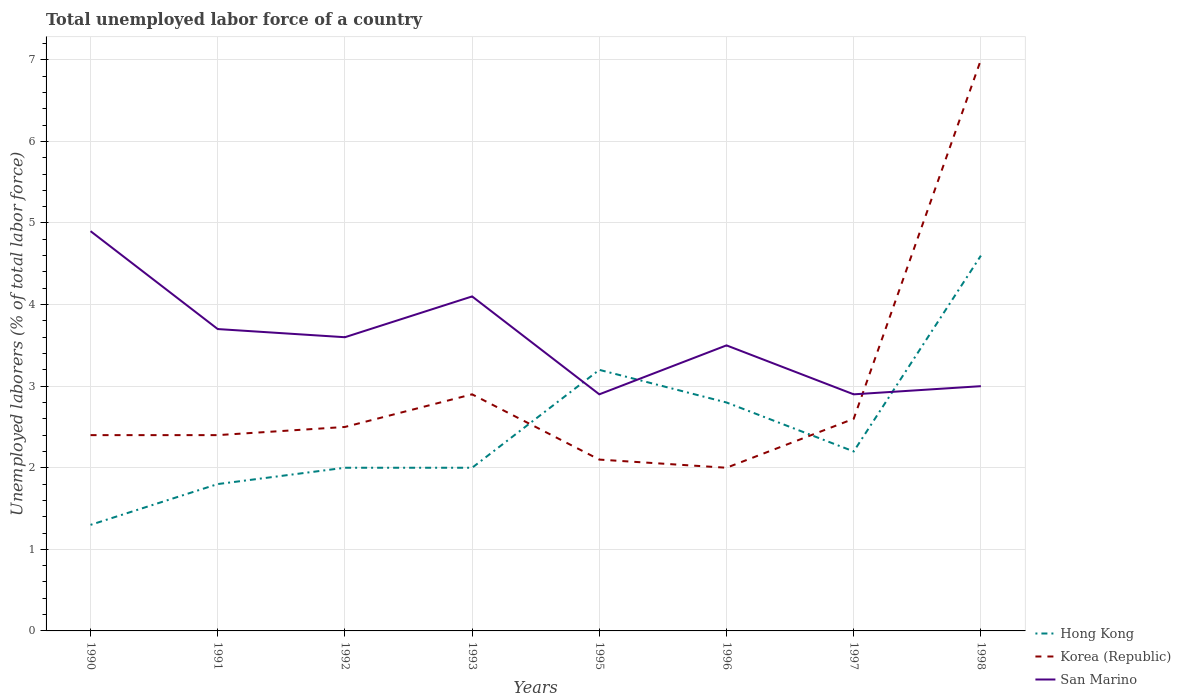How many different coloured lines are there?
Offer a terse response. 3. Is the number of lines equal to the number of legend labels?
Provide a short and direct response. Yes. Across all years, what is the maximum total unemployed labor force in Hong Kong?
Provide a succinct answer. 1.3. What is the total total unemployed labor force in Hong Kong in the graph?
Provide a succinct answer. -0.8. What is the difference between the highest and the second highest total unemployed labor force in Hong Kong?
Make the answer very short. 3.3. What is the difference between the highest and the lowest total unemployed labor force in San Marino?
Provide a short and direct response. 4. How many years are there in the graph?
Provide a short and direct response. 8. Does the graph contain any zero values?
Make the answer very short. No. Where does the legend appear in the graph?
Provide a succinct answer. Bottom right. How many legend labels are there?
Your answer should be very brief. 3. How are the legend labels stacked?
Offer a very short reply. Vertical. What is the title of the graph?
Give a very brief answer. Total unemployed labor force of a country. Does "Honduras" appear as one of the legend labels in the graph?
Ensure brevity in your answer.  No. What is the label or title of the X-axis?
Make the answer very short. Years. What is the label or title of the Y-axis?
Give a very brief answer. Unemployed laborers (% of total labor force). What is the Unemployed laborers (% of total labor force) in Hong Kong in 1990?
Your answer should be compact. 1.3. What is the Unemployed laborers (% of total labor force) in Korea (Republic) in 1990?
Your response must be concise. 2.4. What is the Unemployed laborers (% of total labor force) of San Marino in 1990?
Make the answer very short. 4.9. What is the Unemployed laborers (% of total labor force) of Hong Kong in 1991?
Keep it short and to the point. 1.8. What is the Unemployed laborers (% of total labor force) of Korea (Republic) in 1991?
Ensure brevity in your answer.  2.4. What is the Unemployed laborers (% of total labor force) in San Marino in 1991?
Make the answer very short. 3.7. What is the Unemployed laborers (% of total labor force) in Korea (Republic) in 1992?
Ensure brevity in your answer.  2.5. What is the Unemployed laborers (% of total labor force) in San Marino in 1992?
Your answer should be compact. 3.6. What is the Unemployed laborers (% of total labor force) in Hong Kong in 1993?
Keep it short and to the point. 2. What is the Unemployed laborers (% of total labor force) of Korea (Republic) in 1993?
Ensure brevity in your answer.  2.9. What is the Unemployed laborers (% of total labor force) of San Marino in 1993?
Offer a terse response. 4.1. What is the Unemployed laborers (% of total labor force) of Hong Kong in 1995?
Offer a terse response. 3.2. What is the Unemployed laborers (% of total labor force) of Korea (Republic) in 1995?
Provide a succinct answer. 2.1. What is the Unemployed laborers (% of total labor force) in San Marino in 1995?
Ensure brevity in your answer.  2.9. What is the Unemployed laborers (% of total labor force) of Hong Kong in 1996?
Offer a very short reply. 2.8. What is the Unemployed laborers (% of total labor force) in San Marino in 1996?
Keep it short and to the point. 3.5. What is the Unemployed laborers (% of total labor force) in Hong Kong in 1997?
Give a very brief answer. 2.2. What is the Unemployed laborers (% of total labor force) in Korea (Republic) in 1997?
Offer a very short reply. 2.6. What is the Unemployed laborers (% of total labor force) in San Marino in 1997?
Make the answer very short. 2.9. What is the Unemployed laborers (% of total labor force) of Hong Kong in 1998?
Your response must be concise. 4.6. What is the Unemployed laborers (% of total labor force) in San Marino in 1998?
Keep it short and to the point. 3. Across all years, what is the maximum Unemployed laborers (% of total labor force) in Hong Kong?
Your answer should be very brief. 4.6. Across all years, what is the maximum Unemployed laborers (% of total labor force) in Korea (Republic)?
Offer a terse response. 7. Across all years, what is the maximum Unemployed laborers (% of total labor force) in San Marino?
Your response must be concise. 4.9. Across all years, what is the minimum Unemployed laborers (% of total labor force) in Hong Kong?
Offer a very short reply. 1.3. Across all years, what is the minimum Unemployed laborers (% of total labor force) of San Marino?
Your response must be concise. 2.9. What is the total Unemployed laborers (% of total labor force) of Hong Kong in the graph?
Offer a terse response. 19.9. What is the total Unemployed laborers (% of total labor force) of Korea (Republic) in the graph?
Your answer should be compact. 23.9. What is the total Unemployed laborers (% of total labor force) in San Marino in the graph?
Your response must be concise. 28.6. What is the difference between the Unemployed laborers (% of total labor force) in San Marino in 1990 and that in 1991?
Keep it short and to the point. 1.2. What is the difference between the Unemployed laborers (% of total labor force) in San Marino in 1990 and that in 1992?
Make the answer very short. 1.3. What is the difference between the Unemployed laborers (% of total labor force) in Hong Kong in 1990 and that in 1993?
Your answer should be compact. -0.7. What is the difference between the Unemployed laborers (% of total labor force) in Hong Kong in 1990 and that in 1995?
Offer a terse response. -1.9. What is the difference between the Unemployed laborers (% of total labor force) in Korea (Republic) in 1990 and that in 1995?
Your response must be concise. 0.3. What is the difference between the Unemployed laborers (% of total labor force) of Hong Kong in 1990 and that in 1996?
Offer a terse response. -1.5. What is the difference between the Unemployed laborers (% of total labor force) of Korea (Republic) in 1990 and that in 1996?
Provide a succinct answer. 0.4. What is the difference between the Unemployed laborers (% of total labor force) in Hong Kong in 1990 and that in 1997?
Offer a terse response. -0.9. What is the difference between the Unemployed laborers (% of total labor force) of San Marino in 1990 and that in 1997?
Provide a short and direct response. 2. What is the difference between the Unemployed laborers (% of total labor force) of Hong Kong in 1990 and that in 1998?
Offer a terse response. -3.3. What is the difference between the Unemployed laborers (% of total labor force) in Korea (Republic) in 1990 and that in 1998?
Ensure brevity in your answer.  -4.6. What is the difference between the Unemployed laborers (% of total labor force) in Hong Kong in 1991 and that in 1992?
Offer a terse response. -0.2. What is the difference between the Unemployed laborers (% of total labor force) of Korea (Republic) in 1991 and that in 1992?
Provide a short and direct response. -0.1. What is the difference between the Unemployed laborers (% of total labor force) of San Marino in 1991 and that in 1992?
Provide a short and direct response. 0.1. What is the difference between the Unemployed laborers (% of total labor force) in Hong Kong in 1991 and that in 1993?
Make the answer very short. -0.2. What is the difference between the Unemployed laborers (% of total labor force) of San Marino in 1991 and that in 1993?
Offer a terse response. -0.4. What is the difference between the Unemployed laborers (% of total labor force) of Hong Kong in 1991 and that in 1995?
Provide a succinct answer. -1.4. What is the difference between the Unemployed laborers (% of total labor force) of Hong Kong in 1991 and that in 1996?
Keep it short and to the point. -1. What is the difference between the Unemployed laborers (% of total labor force) of Hong Kong in 1991 and that in 1997?
Offer a very short reply. -0.4. What is the difference between the Unemployed laborers (% of total labor force) of San Marino in 1991 and that in 1997?
Provide a short and direct response. 0.8. What is the difference between the Unemployed laborers (% of total labor force) of Korea (Republic) in 1991 and that in 1998?
Ensure brevity in your answer.  -4.6. What is the difference between the Unemployed laborers (% of total labor force) of Korea (Republic) in 1992 and that in 1993?
Provide a short and direct response. -0.4. What is the difference between the Unemployed laborers (% of total labor force) of San Marino in 1992 and that in 1993?
Keep it short and to the point. -0.5. What is the difference between the Unemployed laborers (% of total labor force) of Hong Kong in 1992 and that in 1996?
Make the answer very short. -0.8. What is the difference between the Unemployed laborers (% of total labor force) in Korea (Republic) in 1992 and that in 1996?
Make the answer very short. 0.5. What is the difference between the Unemployed laborers (% of total labor force) of San Marino in 1992 and that in 1996?
Ensure brevity in your answer.  0.1. What is the difference between the Unemployed laborers (% of total labor force) of Hong Kong in 1992 and that in 1997?
Your answer should be very brief. -0.2. What is the difference between the Unemployed laborers (% of total labor force) in Korea (Republic) in 1992 and that in 1997?
Your response must be concise. -0.1. What is the difference between the Unemployed laborers (% of total labor force) in San Marino in 1992 and that in 1997?
Your response must be concise. 0.7. What is the difference between the Unemployed laborers (% of total labor force) in Korea (Republic) in 1993 and that in 1995?
Give a very brief answer. 0.8. What is the difference between the Unemployed laborers (% of total labor force) in Hong Kong in 1993 and that in 1996?
Provide a succinct answer. -0.8. What is the difference between the Unemployed laborers (% of total labor force) in San Marino in 1993 and that in 1996?
Make the answer very short. 0.6. What is the difference between the Unemployed laborers (% of total labor force) of Korea (Republic) in 1993 and that in 1997?
Make the answer very short. 0.3. What is the difference between the Unemployed laborers (% of total labor force) in Hong Kong in 1993 and that in 1998?
Make the answer very short. -2.6. What is the difference between the Unemployed laborers (% of total labor force) in Korea (Republic) in 1993 and that in 1998?
Offer a very short reply. -4.1. What is the difference between the Unemployed laborers (% of total labor force) of San Marino in 1993 and that in 1998?
Make the answer very short. 1.1. What is the difference between the Unemployed laborers (% of total labor force) of Hong Kong in 1995 and that in 1996?
Your answer should be very brief. 0.4. What is the difference between the Unemployed laborers (% of total labor force) in Korea (Republic) in 1995 and that in 1996?
Your answer should be very brief. 0.1. What is the difference between the Unemployed laborers (% of total labor force) in Korea (Republic) in 1995 and that in 1997?
Your answer should be compact. -0.5. What is the difference between the Unemployed laborers (% of total labor force) of Hong Kong in 1995 and that in 1998?
Keep it short and to the point. -1.4. What is the difference between the Unemployed laborers (% of total labor force) in Hong Kong in 1996 and that in 1997?
Your answer should be compact. 0.6. What is the difference between the Unemployed laborers (% of total labor force) in Korea (Republic) in 1996 and that in 1997?
Offer a very short reply. -0.6. What is the difference between the Unemployed laborers (% of total labor force) in San Marino in 1996 and that in 1998?
Provide a short and direct response. 0.5. What is the difference between the Unemployed laborers (% of total labor force) in Hong Kong in 1997 and that in 1998?
Your answer should be compact. -2.4. What is the difference between the Unemployed laborers (% of total labor force) in San Marino in 1997 and that in 1998?
Your answer should be compact. -0.1. What is the difference between the Unemployed laborers (% of total labor force) in Hong Kong in 1990 and the Unemployed laborers (% of total labor force) in San Marino in 1991?
Offer a terse response. -2.4. What is the difference between the Unemployed laborers (% of total labor force) in Korea (Republic) in 1990 and the Unemployed laborers (% of total labor force) in San Marino in 1993?
Your answer should be compact. -1.7. What is the difference between the Unemployed laborers (% of total labor force) of Hong Kong in 1990 and the Unemployed laborers (% of total labor force) of Korea (Republic) in 1995?
Your answer should be compact. -0.8. What is the difference between the Unemployed laborers (% of total labor force) of Korea (Republic) in 1990 and the Unemployed laborers (% of total labor force) of San Marino in 1996?
Give a very brief answer. -1.1. What is the difference between the Unemployed laborers (% of total labor force) of Hong Kong in 1990 and the Unemployed laborers (% of total labor force) of Korea (Republic) in 1997?
Provide a succinct answer. -1.3. What is the difference between the Unemployed laborers (% of total labor force) of Korea (Republic) in 1990 and the Unemployed laborers (% of total labor force) of San Marino in 1997?
Provide a short and direct response. -0.5. What is the difference between the Unemployed laborers (% of total labor force) of Hong Kong in 1991 and the Unemployed laborers (% of total labor force) of Korea (Republic) in 1992?
Make the answer very short. -0.7. What is the difference between the Unemployed laborers (% of total labor force) in Hong Kong in 1991 and the Unemployed laborers (% of total labor force) in San Marino in 1992?
Keep it short and to the point. -1.8. What is the difference between the Unemployed laborers (% of total labor force) of Korea (Republic) in 1991 and the Unemployed laborers (% of total labor force) of San Marino in 1992?
Offer a terse response. -1.2. What is the difference between the Unemployed laborers (% of total labor force) in Hong Kong in 1991 and the Unemployed laborers (% of total labor force) in Korea (Republic) in 1995?
Your response must be concise. -0.3. What is the difference between the Unemployed laborers (% of total labor force) of Hong Kong in 1991 and the Unemployed laborers (% of total labor force) of San Marino in 1995?
Make the answer very short. -1.1. What is the difference between the Unemployed laborers (% of total labor force) of Hong Kong in 1991 and the Unemployed laborers (% of total labor force) of San Marino in 1996?
Keep it short and to the point. -1.7. What is the difference between the Unemployed laborers (% of total labor force) in Hong Kong in 1991 and the Unemployed laborers (% of total labor force) in Korea (Republic) in 1997?
Ensure brevity in your answer.  -0.8. What is the difference between the Unemployed laborers (% of total labor force) of Hong Kong in 1991 and the Unemployed laborers (% of total labor force) of Korea (Republic) in 1998?
Provide a short and direct response. -5.2. What is the difference between the Unemployed laborers (% of total labor force) of Hong Kong in 1991 and the Unemployed laborers (% of total labor force) of San Marino in 1998?
Keep it short and to the point. -1.2. What is the difference between the Unemployed laborers (% of total labor force) in Hong Kong in 1992 and the Unemployed laborers (% of total labor force) in Korea (Republic) in 1993?
Provide a short and direct response. -0.9. What is the difference between the Unemployed laborers (% of total labor force) of Hong Kong in 1992 and the Unemployed laborers (% of total labor force) of San Marino in 1993?
Keep it short and to the point. -2.1. What is the difference between the Unemployed laborers (% of total labor force) of Korea (Republic) in 1992 and the Unemployed laborers (% of total labor force) of San Marino in 1993?
Ensure brevity in your answer.  -1.6. What is the difference between the Unemployed laborers (% of total labor force) in Hong Kong in 1992 and the Unemployed laborers (% of total labor force) in Korea (Republic) in 1995?
Keep it short and to the point. -0.1. What is the difference between the Unemployed laborers (% of total labor force) in Hong Kong in 1992 and the Unemployed laborers (% of total labor force) in San Marino in 1995?
Your answer should be compact. -0.9. What is the difference between the Unemployed laborers (% of total labor force) of Korea (Republic) in 1992 and the Unemployed laborers (% of total labor force) of San Marino in 1995?
Make the answer very short. -0.4. What is the difference between the Unemployed laborers (% of total labor force) in Hong Kong in 1992 and the Unemployed laborers (% of total labor force) in Korea (Republic) in 1996?
Offer a terse response. 0. What is the difference between the Unemployed laborers (% of total labor force) in Hong Kong in 1992 and the Unemployed laborers (% of total labor force) in Korea (Republic) in 1997?
Offer a very short reply. -0.6. What is the difference between the Unemployed laborers (% of total labor force) of Hong Kong in 1992 and the Unemployed laborers (% of total labor force) of Korea (Republic) in 1998?
Provide a succinct answer. -5. What is the difference between the Unemployed laborers (% of total labor force) in Hong Kong in 1993 and the Unemployed laborers (% of total labor force) in San Marino in 1995?
Make the answer very short. -0.9. What is the difference between the Unemployed laborers (% of total labor force) in Hong Kong in 1993 and the Unemployed laborers (% of total labor force) in Korea (Republic) in 1996?
Provide a succinct answer. 0. What is the difference between the Unemployed laborers (% of total labor force) in Hong Kong in 1993 and the Unemployed laborers (% of total labor force) in San Marino in 1996?
Provide a short and direct response. -1.5. What is the difference between the Unemployed laborers (% of total labor force) of Hong Kong in 1993 and the Unemployed laborers (% of total labor force) of San Marino in 1998?
Ensure brevity in your answer.  -1. What is the difference between the Unemployed laborers (% of total labor force) of Korea (Republic) in 1993 and the Unemployed laborers (% of total labor force) of San Marino in 1998?
Keep it short and to the point. -0.1. What is the difference between the Unemployed laborers (% of total labor force) in Hong Kong in 1995 and the Unemployed laborers (% of total labor force) in San Marino in 1997?
Offer a terse response. 0.3. What is the difference between the Unemployed laborers (% of total labor force) in Hong Kong in 1996 and the Unemployed laborers (% of total labor force) in Korea (Republic) in 1997?
Your answer should be compact. 0.2. What is the difference between the Unemployed laborers (% of total labor force) in Korea (Republic) in 1996 and the Unemployed laborers (% of total labor force) in San Marino in 1997?
Ensure brevity in your answer.  -0.9. What is the difference between the Unemployed laborers (% of total labor force) of Hong Kong in 1996 and the Unemployed laborers (% of total labor force) of Korea (Republic) in 1998?
Ensure brevity in your answer.  -4.2. What is the difference between the Unemployed laborers (% of total labor force) of Hong Kong in 1996 and the Unemployed laborers (% of total labor force) of San Marino in 1998?
Ensure brevity in your answer.  -0.2. What is the difference between the Unemployed laborers (% of total labor force) of Korea (Republic) in 1996 and the Unemployed laborers (% of total labor force) of San Marino in 1998?
Make the answer very short. -1. What is the difference between the Unemployed laborers (% of total labor force) of Hong Kong in 1997 and the Unemployed laborers (% of total labor force) of San Marino in 1998?
Your response must be concise. -0.8. What is the average Unemployed laborers (% of total labor force) in Hong Kong per year?
Provide a short and direct response. 2.49. What is the average Unemployed laborers (% of total labor force) in Korea (Republic) per year?
Provide a succinct answer. 2.99. What is the average Unemployed laborers (% of total labor force) of San Marino per year?
Your answer should be compact. 3.58. In the year 1990, what is the difference between the Unemployed laborers (% of total labor force) of Hong Kong and Unemployed laborers (% of total labor force) of Korea (Republic)?
Offer a terse response. -1.1. In the year 1990, what is the difference between the Unemployed laborers (% of total labor force) of Hong Kong and Unemployed laborers (% of total labor force) of San Marino?
Make the answer very short. -3.6. In the year 1990, what is the difference between the Unemployed laborers (% of total labor force) of Korea (Republic) and Unemployed laborers (% of total labor force) of San Marino?
Your response must be concise. -2.5. In the year 1991, what is the difference between the Unemployed laborers (% of total labor force) of Hong Kong and Unemployed laborers (% of total labor force) of Korea (Republic)?
Make the answer very short. -0.6. In the year 1992, what is the difference between the Unemployed laborers (% of total labor force) in Korea (Republic) and Unemployed laborers (% of total labor force) in San Marino?
Provide a short and direct response. -1.1. In the year 1993, what is the difference between the Unemployed laborers (% of total labor force) of Hong Kong and Unemployed laborers (% of total labor force) of San Marino?
Your answer should be very brief. -2.1. In the year 1993, what is the difference between the Unemployed laborers (% of total labor force) of Korea (Republic) and Unemployed laborers (% of total labor force) of San Marino?
Give a very brief answer. -1.2. In the year 1995, what is the difference between the Unemployed laborers (% of total labor force) of Hong Kong and Unemployed laborers (% of total labor force) of Korea (Republic)?
Offer a very short reply. 1.1. In the year 1995, what is the difference between the Unemployed laborers (% of total labor force) in Hong Kong and Unemployed laborers (% of total labor force) in San Marino?
Keep it short and to the point. 0.3. In the year 1995, what is the difference between the Unemployed laborers (% of total labor force) of Korea (Republic) and Unemployed laborers (% of total labor force) of San Marino?
Keep it short and to the point. -0.8. In the year 1996, what is the difference between the Unemployed laborers (% of total labor force) of Hong Kong and Unemployed laborers (% of total labor force) of Korea (Republic)?
Your response must be concise. 0.8. In the year 1996, what is the difference between the Unemployed laborers (% of total labor force) in Hong Kong and Unemployed laborers (% of total labor force) in San Marino?
Keep it short and to the point. -0.7. In the year 1997, what is the difference between the Unemployed laborers (% of total labor force) of Hong Kong and Unemployed laborers (% of total labor force) of Korea (Republic)?
Provide a succinct answer. -0.4. In the year 1997, what is the difference between the Unemployed laborers (% of total labor force) in Hong Kong and Unemployed laborers (% of total labor force) in San Marino?
Give a very brief answer. -0.7. In the year 1997, what is the difference between the Unemployed laborers (% of total labor force) of Korea (Republic) and Unemployed laborers (% of total labor force) of San Marino?
Ensure brevity in your answer.  -0.3. In the year 1998, what is the difference between the Unemployed laborers (% of total labor force) of Hong Kong and Unemployed laborers (% of total labor force) of Korea (Republic)?
Make the answer very short. -2.4. In the year 1998, what is the difference between the Unemployed laborers (% of total labor force) in Korea (Republic) and Unemployed laborers (% of total labor force) in San Marino?
Your answer should be compact. 4. What is the ratio of the Unemployed laborers (% of total labor force) in Hong Kong in 1990 to that in 1991?
Offer a terse response. 0.72. What is the ratio of the Unemployed laborers (% of total labor force) in Korea (Republic) in 1990 to that in 1991?
Your response must be concise. 1. What is the ratio of the Unemployed laborers (% of total labor force) in San Marino in 1990 to that in 1991?
Your answer should be compact. 1.32. What is the ratio of the Unemployed laborers (% of total labor force) of Hong Kong in 1990 to that in 1992?
Give a very brief answer. 0.65. What is the ratio of the Unemployed laborers (% of total labor force) in Korea (Republic) in 1990 to that in 1992?
Your answer should be compact. 0.96. What is the ratio of the Unemployed laborers (% of total labor force) of San Marino in 1990 to that in 1992?
Keep it short and to the point. 1.36. What is the ratio of the Unemployed laborers (% of total labor force) of Hong Kong in 1990 to that in 1993?
Your answer should be compact. 0.65. What is the ratio of the Unemployed laborers (% of total labor force) in Korea (Republic) in 1990 to that in 1993?
Keep it short and to the point. 0.83. What is the ratio of the Unemployed laborers (% of total labor force) in San Marino in 1990 to that in 1993?
Your response must be concise. 1.2. What is the ratio of the Unemployed laborers (% of total labor force) of Hong Kong in 1990 to that in 1995?
Make the answer very short. 0.41. What is the ratio of the Unemployed laborers (% of total labor force) in Korea (Republic) in 1990 to that in 1995?
Provide a succinct answer. 1.14. What is the ratio of the Unemployed laborers (% of total labor force) in San Marino in 1990 to that in 1995?
Give a very brief answer. 1.69. What is the ratio of the Unemployed laborers (% of total labor force) in Hong Kong in 1990 to that in 1996?
Provide a succinct answer. 0.46. What is the ratio of the Unemployed laborers (% of total labor force) of Korea (Republic) in 1990 to that in 1996?
Make the answer very short. 1.2. What is the ratio of the Unemployed laborers (% of total labor force) in Hong Kong in 1990 to that in 1997?
Ensure brevity in your answer.  0.59. What is the ratio of the Unemployed laborers (% of total labor force) in San Marino in 1990 to that in 1997?
Keep it short and to the point. 1.69. What is the ratio of the Unemployed laborers (% of total labor force) in Hong Kong in 1990 to that in 1998?
Your answer should be very brief. 0.28. What is the ratio of the Unemployed laborers (% of total labor force) of Korea (Republic) in 1990 to that in 1998?
Your answer should be compact. 0.34. What is the ratio of the Unemployed laborers (% of total labor force) of San Marino in 1990 to that in 1998?
Your answer should be very brief. 1.63. What is the ratio of the Unemployed laborers (% of total labor force) in Hong Kong in 1991 to that in 1992?
Your answer should be compact. 0.9. What is the ratio of the Unemployed laborers (% of total labor force) of Korea (Republic) in 1991 to that in 1992?
Make the answer very short. 0.96. What is the ratio of the Unemployed laborers (% of total labor force) of San Marino in 1991 to that in 1992?
Offer a very short reply. 1.03. What is the ratio of the Unemployed laborers (% of total labor force) in Korea (Republic) in 1991 to that in 1993?
Provide a succinct answer. 0.83. What is the ratio of the Unemployed laborers (% of total labor force) in San Marino in 1991 to that in 1993?
Ensure brevity in your answer.  0.9. What is the ratio of the Unemployed laborers (% of total labor force) of Hong Kong in 1991 to that in 1995?
Provide a succinct answer. 0.56. What is the ratio of the Unemployed laborers (% of total labor force) of Korea (Republic) in 1991 to that in 1995?
Your answer should be compact. 1.14. What is the ratio of the Unemployed laborers (% of total labor force) in San Marino in 1991 to that in 1995?
Keep it short and to the point. 1.28. What is the ratio of the Unemployed laborers (% of total labor force) of Hong Kong in 1991 to that in 1996?
Provide a short and direct response. 0.64. What is the ratio of the Unemployed laborers (% of total labor force) of San Marino in 1991 to that in 1996?
Offer a terse response. 1.06. What is the ratio of the Unemployed laborers (% of total labor force) in Hong Kong in 1991 to that in 1997?
Your answer should be compact. 0.82. What is the ratio of the Unemployed laborers (% of total labor force) in Korea (Republic) in 1991 to that in 1997?
Your answer should be very brief. 0.92. What is the ratio of the Unemployed laborers (% of total labor force) in San Marino in 1991 to that in 1997?
Make the answer very short. 1.28. What is the ratio of the Unemployed laborers (% of total labor force) of Hong Kong in 1991 to that in 1998?
Give a very brief answer. 0.39. What is the ratio of the Unemployed laborers (% of total labor force) in Korea (Republic) in 1991 to that in 1998?
Your answer should be very brief. 0.34. What is the ratio of the Unemployed laborers (% of total labor force) in San Marino in 1991 to that in 1998?
Your answer should be very brief. 1.23. What is the ratio of the Unemployed laborers (% of total labor force) in Korea (Republic) in 1992 to that in 1993?
Make the answer very short. 0.86. What is the ratio of the Unemployed laborers (% of total labor force) in San Marino in 1992 to that in 1993?
Ensure brevity in your answer.  0.88. What is the ratio of the Unemployed laborers (% of total labor force) of Korea (Republic) in 1992 to that in 1995?
Make the answer very short. 1.19. What is the ratio of the Unemployed laborers (% of total labor force) in San Marino in 1992 to that in 1995?
Offer a very short reply. 1.24. What is the ratio of the Unemployed laborers (% of total labor force) of Hong Kong in 1992 to that in 1996?
Give a very brief answer. 0.71. What is the ratio of the Unemployed laborers (% of total labor force) in San Marino in 1992 to that in 1996?
Offer a very short reply. 1.03. What is the ratio of the Unemployed laborers (% of total labor force) in Hong Kong in 1992 to that in 1997?
Make the answer very short. 0.91. What is the ratio of the Unemployed laborers (% of total labor force) in Korea (Republic) in 1992 to that in 1997?
Keep it short and to the point. 0.96. What is the ratio of the Unemployed laborers (% of total labor force) in San Marino in 1992 to that in 1997?
Give a very brief answer. 1.24. What is the ratio of the Unemployed laborers (% of total labor force) in Hong Kong in 1992 to that in 1998?
Keep it short and to the point. 0.43. What is the ratio of the Unemployed laborers (% of total labor force) in Korea (Republic) in 1992 to that in 1998?
Keep it short and to the point. 0.36. What is the ratio of the Unemployed laborers (% of total labor force) of San Marino in 1992 to that in 1998?
Your answer should be very brief. 1.2. What is the ratio of the Unemployed laborers (% of total labor force) in Korea (Republic) in 1993 to that in 1995?
Provide a succinct answer. 1.38. What is the ratio of the Unemployed laborers (% of total labor force) in San Marino in 1993 to that in 1995?
Offer a terse response. 1.41. What is the ratio of the Unemployed laborers (% of total labor force) in Hong Kong in 1993 to that in 1996?
Ensure brevity in your answer.  0.71. What is the ratio of the Unemployed laborers (% of total labor force) of Korea (Republic) in 1993 to that in 1996?
Provide a succinct answer. 1.45. What is the ratio of the Unemployed laborers (% of total labor force) in San Marino in 1993 to that in 1996?
Give a very brief answer. 1.17. What is the ratio of the Unemployed laborers (% of total labor force) in Korea (Republic) in 1993 to that in 1997?
Offer a very short reply. 1.12. What is the ratio of the Unemployed laborers (% of total labor force) in San Marino in 1993 to that in 1997?
Give a very brief answer. 1.41. What is the ratio of the Unemployed laborers (% of total labor force) of Hong Kong in 1993 to that in 1998?
Make the answer very short. 0.43. What is the ratio of the Unemployed laborers (% of total labor force) in Korea (Republic) in 1993 to that in 1998?
Keep it short and to the point. 0.41. What is the ratio of the Unemployed laborers (% of total labor force) in San Marino in 1993 to that in 1998?
Ensure brevity in your answer.  1.37. What is the ratio of the Unemployed laborers (% of total labor force) of Hong Kong in 1995 to that in 1996?
Ensure brevity in your answer.  1.14. What is the ratio of the Unemployed laborers (% of total labor force) in Korea (Republic) in 1995 to that in 1996?
Provide a succinct answer. 1.05. What is the ratio of the Unemployed laborers (% of total labor force) of San Marino in 1995 to that in 1996?
Give a very brief answer. 0.83. What is the ratio of the Unemployed laborers (% of total labor force) of Hong Kong in 1995 to that in 1997?
Offer a very short reply. 1.45. What is the ratio of the Unemployed laborers (% of total labor force) in Korea (Republic) in 1995 to that in 1997?
Keep it short and to the point. 0.81. What is the ratio of the Unemployed laborers (% of total labor force) of San Marino in 1995 to that in 1997?
Your answer should be compact. 1. What is the ratio of the Unemployed laborers (% of total labor force) of Hong Kong in 1995 to that in 1998?
Make the answer very short. 0.7. What is the ratio of the Unemployed laborers (% of total labor force) in Korea (Republic) in 1995 to that in 1998?
Ensure brevity in your answer.  0.3. What is the ratio of the Unemployed laborers (% of total labor force) in San Marino in 1995 to that in 1998?
Your answer should be compact. 0.97. What is the ratio of the Unemployed laborers (% of total labor force) in Hong Kong in 1996 to that in 1997?
Your response must be concise. 1.27. What is the ratio of the Unemployed laborers (% of total labor force) of Korea (Republic) in 1996 to that in 1997?
Your response must be concise. 0.77. What is the ratio of the Unemployed laborers (% of total labor force) of San Marino in 1996 to that in 1997?
Give a very brief answer. 1.21. What is the ratio of the Unemployed laborers (% of total labor force) in Hong Kong in 1996 to that in 1998?
Provide a short and direct response. 0.61. What is the ratio of the Unemployed laborers (% of total labor force) of Korea (Republic) in 1996 to that in 1998?
Provide a short and direct response. 0.29. What is the ratio of the Unemployed laborers (% of total labor force) of Hong Kong in 1997 to that in 1998?
Give a very brief answer. 0.48. What is the ratio of the Unemployed laborers (% of total labor force) of Korea (Republic) in 1997 to that in 1998?
Provide a succinct answer. 0.37. What is the ratio of the Unemployed laborers (% of total labor force) of San Marino in 1997 to that in 1998?
Your answer should be very brief. 0.97. What is the difference between the highest and the second highest Unemployed laborers (% of total labor force) in Hong Kong?
Provide a succinct answer. 1.4. What is the difference between the highest and the lowest Unemployed laborers (% of total labor force) in San Marino?
Give a very brief answer. 2. 